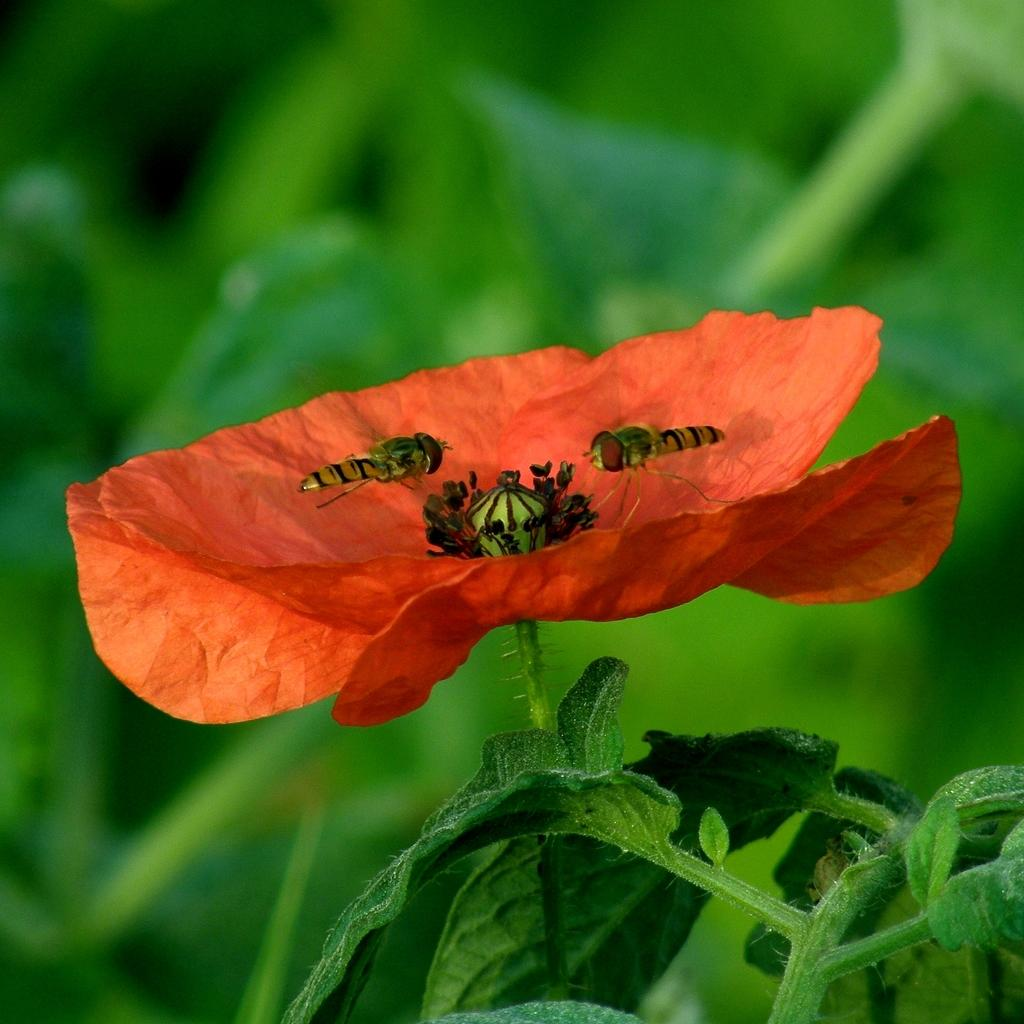What type of flower is featured in the image? There are insects on an orange-colored flower in the image. What else can be seen in the image besides the flower? There are leaves of a plant on the right side of the image. How many kittens are playing with a patch on the mitten in the image? There are no kittens, patches, or mittens present in the image. 